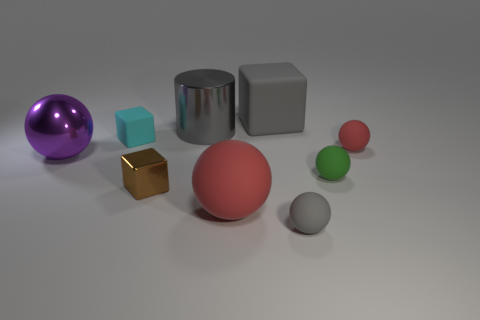There is a purple object; is it the same shape as the large rubber object in front of the small cyan matte cube?
Your answer should be very brief. Yes. Are there the same number of rubber spheres in front of the big gray matte thing and small green matte balls on the left side of the cyan matte object?
Your answer should be very brief. No. The small object that is the same color as the big matte sphere is what shape?
Ensure brevity in your answer.  Sphere. Does the cube that is in front of the big purple metal ball have the same color as the matte sphere to the left of the gray sphere?
Provide a succinct answer. No. Is the number of objects behind the tiny brown metal cube greater than the number of small cubes?
Your answer should be compact. Yes. What is the gray cylinder made of?
Provide a short and direct response. Metal. The small green thing that is the same material as the small red thing is what shape?
Provide a succinct answer. Sphere. There is a red rubber object in front of the red matte object that is right of the small gray object; how big is it?
Your response must be concise. Large. There is a small rubber ball behind the big shiny sphere; what is its color?
Offer a terse response. Red. Are there any large green objects that have the same shape as the tiny green thing?
Provide a succinct answer. No. 